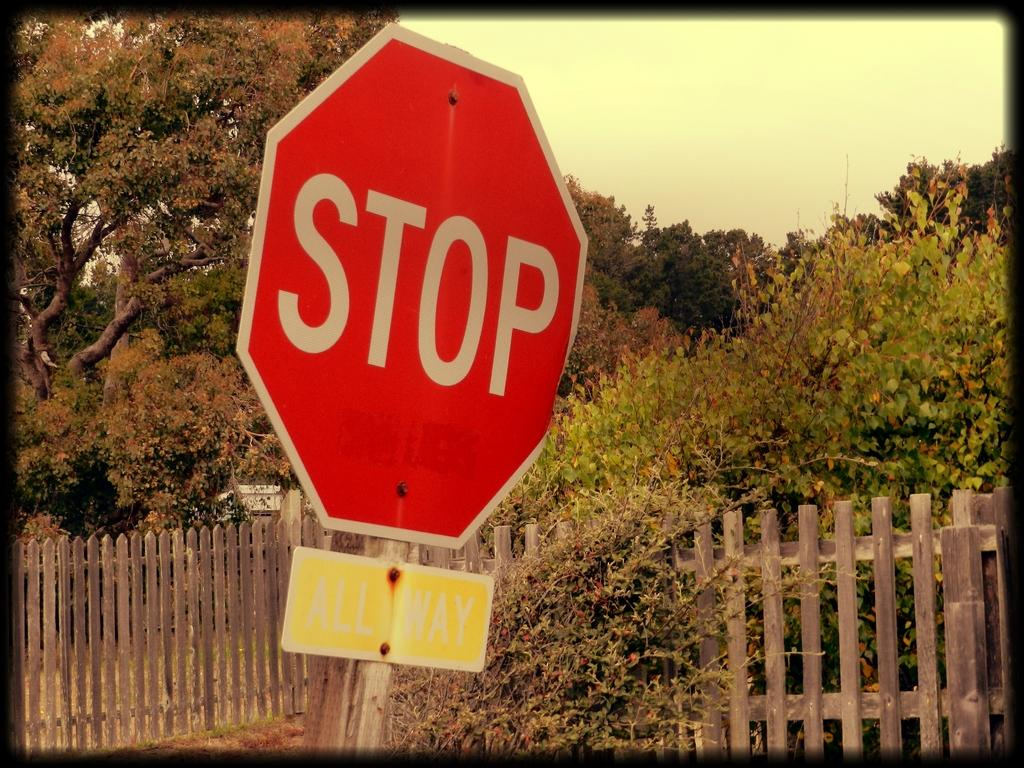Provide a one-sentence caption for the provided image. A red Stop sign slanted on a street side with yellow sign bellow beside a wood fence and a green trees with shrubs. 